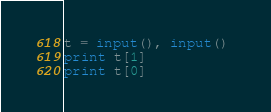<code> <loc_0><loc_0><loc_500><loc_500><_Python_>t = input(), input() 
print t[1] 
print t[0]
</code> 